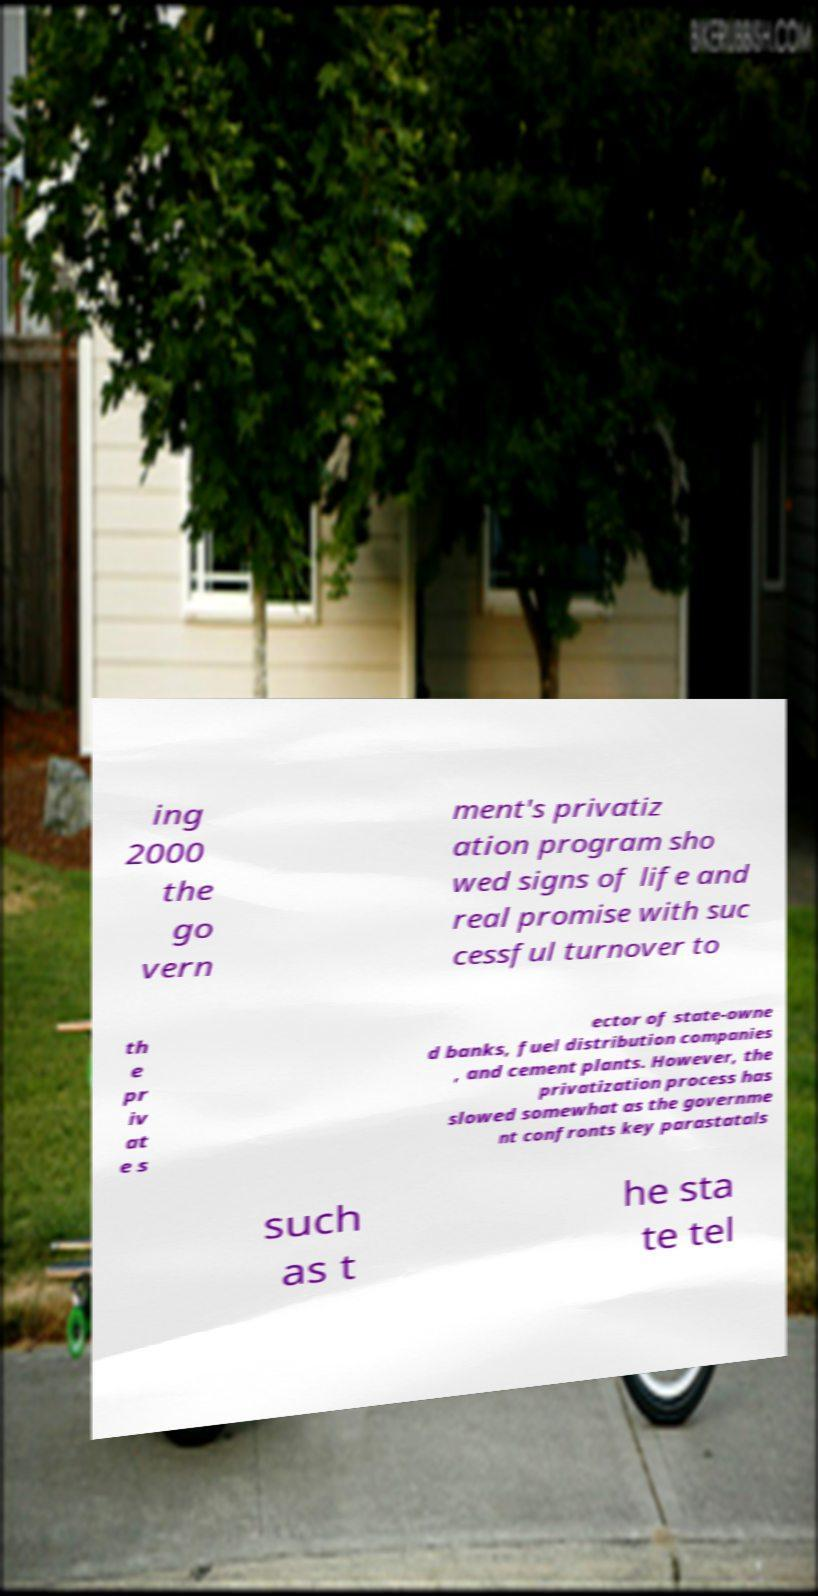I need the written content from this picture converted into text. Can you do that? ing 2000 the go vern ment's privatiz ation program sho wed signs of life and real promise with suc cessful turnover to th e pr iv at e s ector of state-owne d banks, fuel distribution companies , and cement plants. However, the privatization process has slowed somewhat as the governme nt confronts key parastatals such as t he sta te tel 